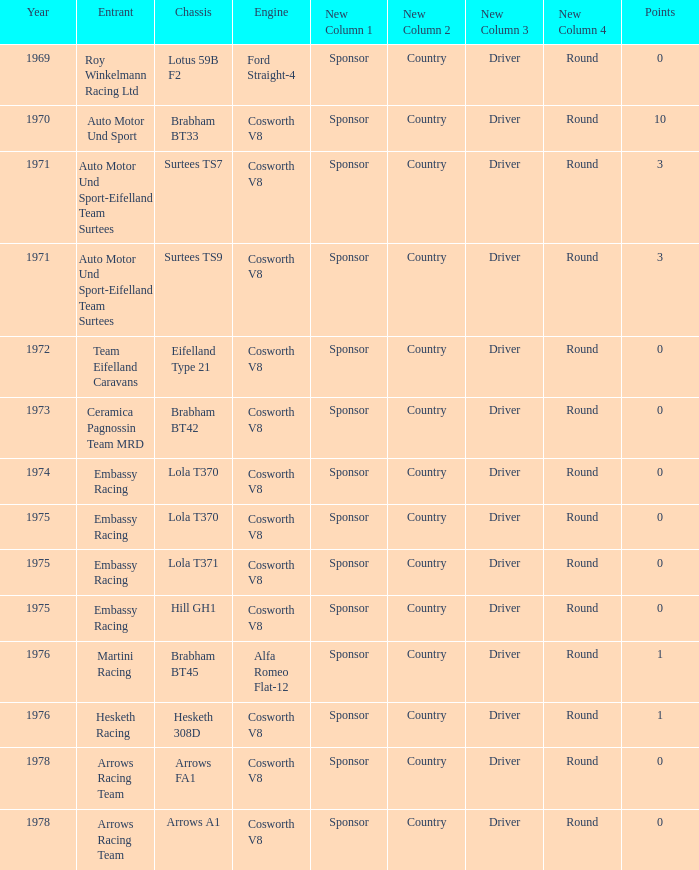In 1970, what entrant had a cosworth v8 engine? Auto Motor Und Sport. 